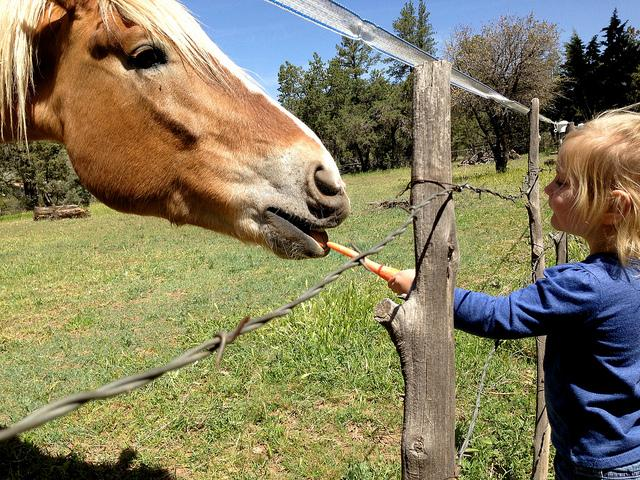What vegetable is toxic to horses? onions 